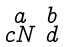<formula> <loc_0><loc_0><loc_500><loc_500>\begin{smallmatrix} a & b \\ c N & d \end{smallmatrix}</formula> 